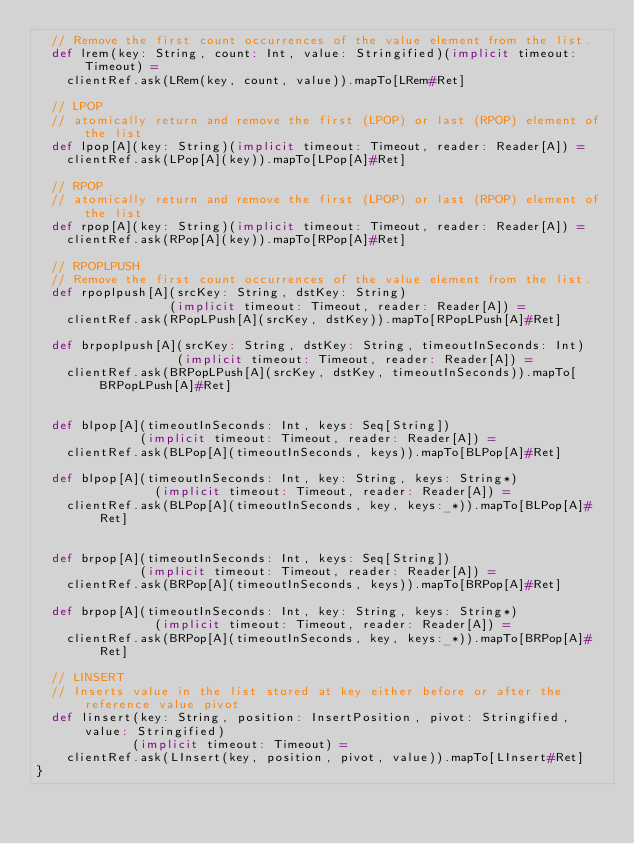<code> <loc_0><loc_0><loc_500><loc_500><_Scala_>  // Remove the first count occurrences of the value element from the list.
  def lrem(key: String, count: Int, value: Stringified)(implicit timeout: Timeout) =
    clientRef.ask(LRem(key, count, value)).mapTo[LRem#Ret]

  // LPOP
  // atomically return and remove the first (LPOP) or last (RPOP) element of the list
  def lpop[A](key: String)(implicit timeout: Timeout, reader: Reader[A]) =
    clientRef.ask(LPop[A](key)).mapTo[LPop[A]#Ret]

  // RPOP
  // atomically return and remove the first (LPOP) or last (RPOP) element of the list
  def rpop[A](key: String)(implicit timeout: Timeout, reader: Reader[A]) =
    clientRef.ask(RPop[A](key)).mapTo[RPop[A]#Ret]

  // RPOPLPUSH
  // Remove the first count occurrences of the value element from the list.
  def rpoplpush[A](srcKey: String, dstKey: String)
                  (implicit timeout: Timeout, reader: Reader[A]) =
    clientRef.ask(RPopLPush[A](srcKey, dstKey)).mapTo[RPopLPush[A]#Ret]

  def brpoplpush[A](srcKey: String, dstKey: String, timeoutInSeconds: Int)
                   (implicit timeout: Timeout, reader: Reader[A]) =
    clientRef.ask(BRPopLPush[A](srcKey, dstKey, timeoutInSeconds)).mapTo[BRPopLPush[A]#Ret]


  def blpop[A](timeoutInSeconds: Int, keys: Seq[String])
              (implicit timeout: Timeout, reader: Reader[A]) =
    clientRef.ask(BLPop[A](timeoutInSeconds, keys)).mapTo[BLPop[A]#Ret]

  def blpop[A](timeoutInSeconds: Int, key: String, keys: String*)
                (implicit timeout: Timeout, reader: Reader[A]) =
    clientRef.ask(BLPop[A](timeoutInSeconds, key, keys:_*)).mapTo[BLPop[A]#Ret]


  def brpop[A](timeoutInSeconds: Int, keys: Seq[String])
              (implicit timeout: Timeout, reader: Reader[A]) =
    clientRef.ask(BRPop[A](timeoutInSeconds, keys)).mapTo[BRPop[A]#Ret]

  def brpop[A](timeoutInSeconds: Int, key: String, keys: String*)
                (implicit timeout: Timeout, reader: Reader[A]) =
    clientRef.ask(BRPop[A](timeoutInSeconds, key, keys:_*)).mapTo[BRPop[A]#Ret]

  // LINSERT
  // Inserts value in the list stored at key either before or after the reference value pivot
  def linsert(key: String, position: InsertPosition, pivot: Stringified, value: Stringified)
             (implicit timeout: Timeout) =
    clientRef.ask(LInsert(key, position, pivot, value)).mapTo[LInsert#Ret]
}
</code> 